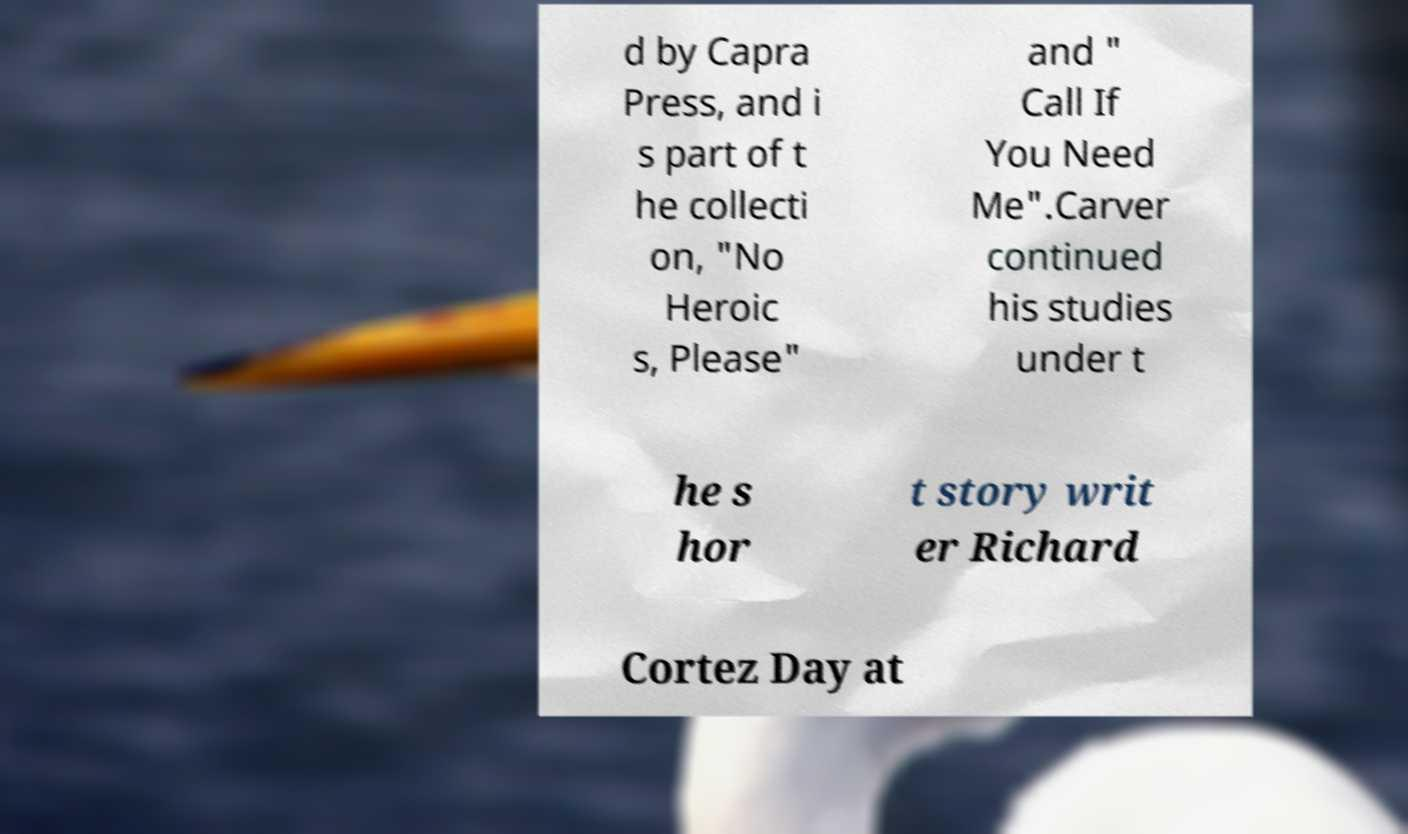Could you assist in decoding the text presented in this image and type it out clearly? d by Capra Press, and i s part of t he collecti on, "No Heroic s, Please" and " Call If You Need Me".Carver continued his studies under t he s hor t story writ er Richard Cortez Day at 